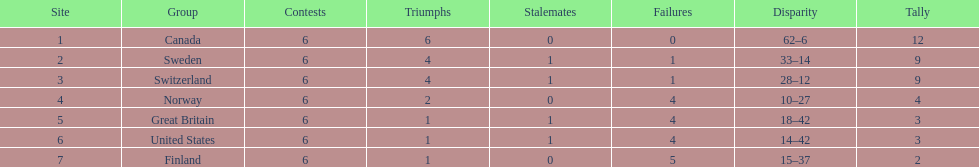Which country performed better during the 1951 world ice hockey championships, switzerland or great britain? Switzerland. 